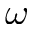Convert formula to latex. <formula><loc_0><loc_0><loc_500><loc_500>\omega</formula> 